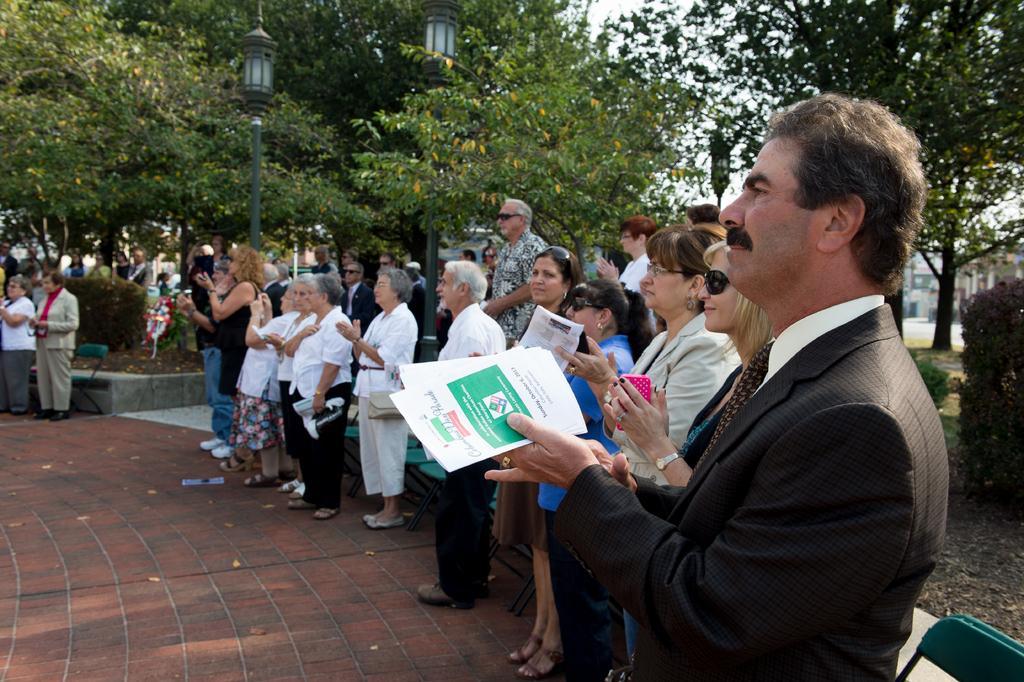Describe this image in one or two sentences. In the image we can see there are lot of trees and there are two street lamp poles. People are gathered and they are applauding and on the ground there are red tiles and there are plants in between the road. 